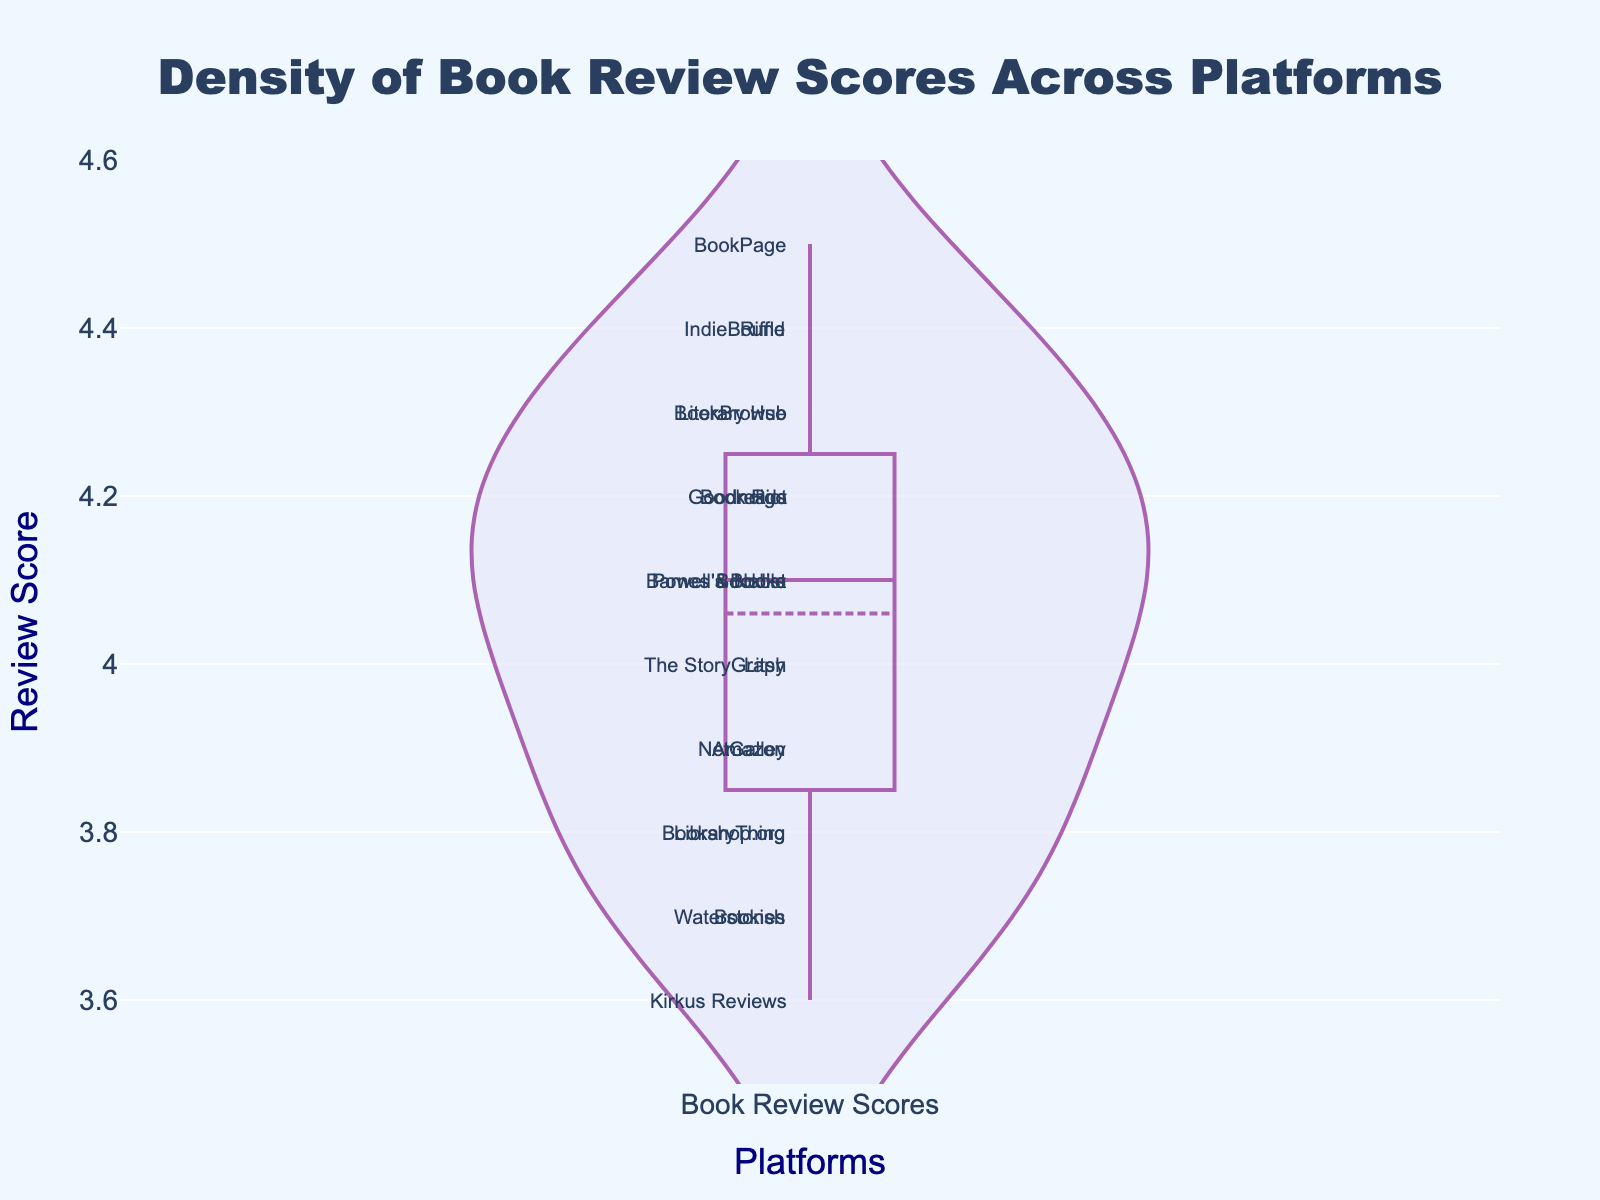What's the title of the plot? The title of the plot is written at the top center of the figure in a larger font and distinctive color.
Answer: Density of Book Review Scores Across Platforms What is the y-axis range in the plot? The y-axis range is shown alongside the y-axis, indicating the minimum and maximum values.
Answer: 3.5 to 4.6 Which platform has the highest review score? The highest point on the y-axis labeled with a platform name indicates the highest review score.
Answer: BookPage Which platform has the lowest review score? The lowest point on the y-axis labeled with a platform name indicates the lowest review score.
Answer: Kirkus Reviews How many platforms have review scores above 4.0? Count the number of platform annotations that appear above the 4.0 mark on the y-axis.
Answer: 11 What is the average review score across all platforms? Sum all the review scores and then divide by the total number of platforms (20). Calculated as (4.2 + 3.9 + 4.1 + 3.8 + 4.3 + 4.0 + 3.7 + 4.4 + 4.5 + 3.6 + 4.2 + 3.9 + 4.1 + 4.3 + 4.0 + 3.8 + 4.2 + 3.7 + 4.1 + 4.4) / 20.
Answer: 4.065 Which platform has a score of 4.2? Identify the platform name labeled next to the review score of 4.2 on the y-axis.
Answer: Goodreads, Book Riot, Indigo Are the review scores more densely packed in the higher or lower end? The density plot's shape and how tightly packed the points are around certain values indicate where the scores are more concentrated.
Answer: Higher end What's the median review score across all platforms? The median score is the middle value when all scores are ordered. In a sorted list of 20 scores, the median is the average of the 10th and 11th scores.
Answer: 4.1 Which platforms have the same score? Find platform names that share the same y-axis value and are directly aligned.
Answer: Goodreads, Book Riot, Indigo (4.2), Barnes & Noble, Booklist, Powell's Books (4.1) 